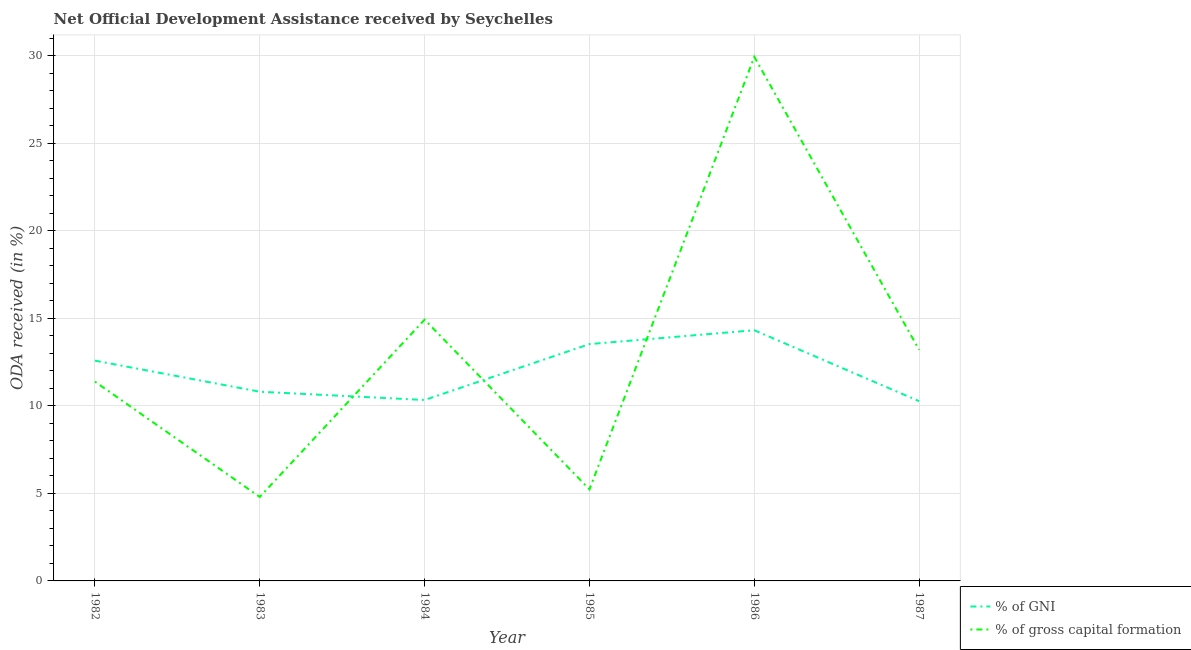Does the line corresponding to oda received as percentage of gross capital formation intersect with the line corresponding to oda received as percentage of gni?
Keep it short and to the point. Yes. What is the oda received as percentage of gross capital formation in 1983?
Provide a succinct answer. 4.8. Across all years, what is the maximum oda received as percentage of gni?
Keep it short and to the point. 14.32. Across all years, what is the minimum oda received as percentage of gni?
Your response must be concise. 10.26. In which year was the oda received as percentage of gross capital formation maximum?
Keep it short and to the point. 1986. In which year was the oda received as percentage of gross capital formation minimum?
Your response must be concise. 1983. What is the total oda received as percentage of gross capital formation in the graph?
Provide a succinct answer. 79.44. What is the difference between the oda received as percentage of gross capital formation in 1984 and that in 1985?
Provide a short and direct response. 9.69. What is the difference between the oda received as percentage of gni in 1986 and the oda received as percentage of gross capital formation in 1987?
Your response must be concise. 1.12. What is the average oda received as percentage of gross capital formation per year?
Offer a very short reply. 13.24. In the year 1984, what is the difference between the oda received as percentage of gross capital formation and oda received as percentage of gni?
Your response must be concise. 4.59. What is the ratio of the oda received as percentage of gni in 1984 to that in 1987?
Provide a short and direct response. 1.01. Is the oda received as percentage of gross capital formation in 1983 less than that in 1985?
Your answer should be very brief. Yes. Is the difference between the oda received as percentage of gni in 1982 and 1986 greater than the difference between the oda received as percentage of gross capital formation in 1982 and 1986?
Make the answer very short. Yes. What is the difference between the highest and the second highest oda received as percentage of gross capital formation?
Give a very brief answer. 15.01. What is the difference between the highest and the lowest oda received as percentage of gross capital formation?
Make the answer very short. 25.13. In how many years, is the oda received as percentage of gni greater than the average oda received as percentage of gni taken over all years?
Your response must be concise. 3. Is the oda received as percentage of gni strictly greater than the oda received as percentage of gross capital formation over the years?
Your response must be concise. No. Is the oda received as percentage of gross capital formation strictly less than the oda received as percentage of gni over the years?
Your answer should be very brief. No. How many years are there in the graph?
Offer a terse response. 6. Are the values on the major ticks of Y-axis written in scientific E-notation?
Keep it short and to the point. No. Does the graph contain grids?
Offer a very short reply. Yes. Where does the legend appear in the graph?
Offer a very short reply. Bottom right. What is the title of the graph?
Your response must be concise. Net Official Development Assistance received by Seychelles. Does "National Visitors" appear as one of the legend labels in the graph?
Your response must be concise. No. What is the label or title of the Y-axis?
Provide a short and direct response. ODA received (in %). What is the ODA received (in %) in % of GNI in 1982?
Ensure brevity in your answer.  12.58. What is the ODA received (in %) of % of gross capital formation in 1982?
Your response must be concise. 11.38. What is the ODA received (in %) of % of GNI in 1983?
Make the answer very short. 10.8. What is the ODA received (in %) in % of gross capital formation in 1983?
Offer a terse response. 4.8. What is the ODA received (in %) in % of GNI in 1984?
Provide a succinct answer. 10.33. What is the ODA received (in %) of % of gross capital formation in 1984?
Your answer should be compact. 14.92. What is the ODA received (in %) in % of GNI in 1985?
Provide a short and direct response. 13.52. What is the ODA received (in %) of % of gross capital formation in 1985?
Provide a short and direct response. 5.23. What is the ODA received (in %) in % of GNI in 1986?
Offer a very short reply. 14.32. What is the ODA received (in %) of % of gross capital formation in 1986?
Your answer should be very brief. 29.92. What is the ODA received (in %) of % of GNI in 1987?
Your response must be concise. 10.26. What is the ODA received (in %) in % of gross capital formation in 1987?
Keep it short and to the point. 13.19. Across all years, what is the maximum ODA received (in %) in % of GNI?
Your response must be concise. 14.32. Across all years, what is the maximum ODA received (in %) of % of gross capital formation?
Offer a terse response. 29.92. Across all years, what is the minimum ODA received (in %) of % of GNI?
Make the answer very short. 10.26. Across all years, what is the minimum ODA received (in %) in % of gross capital formation?
Provide a succinct answer. 4.8. What is the total ODA received (in %) of % of GNI in the graph?
Your answer should be very brief. 71.82. What is the total ODA received (in %) in % of gross capital formation in the graph?
Your answer should be very brief. 79.44. What is the difference between the ODA received (in %) of % of GNI in 1982 and that in 1983?
Your answer should be very brief. 1.78. What is the difference between the ODA received (in %) in % of gross capital formation in 1982 and that in 1983?
Make the answer very short. 6.59. What is the difference between the ODA received (in %) in % of GNI in 1982 and that in 1984?
Make the answer very short. 2.25. What is the difference between the ODA received (in %) in % of gross capital formation in 1982 and that in 1984?
Give a very brief answer. -3.54. What is the difference between the ODA received (in %) of % of GNI in 1982 and that in 1985?
Provide a short and direct response. -0.94. What is the difference between the ODA received (in %) in % of gross capital formation in 1982 and that in 1985?
Give a very brief answer. 6.15. What is the difference between the ODA received (in %) of % of GNI in 1982 and that in 1986?
Give a very brief answer. -1.74. What is the difference between the ODA received (in %) in % of gross capital formation in 1982 and that in 1986?
Your answer should be compact. -18.54. What is the difference between the ODA received (in %) in % of GNI in 1982 and that in 1987?
Offer a terse response. 2.32. What is the difference between the ODA received (in %) in % of gross capital formation in 1982 and that in 1987?
Ensure brevity in your answer.  -1.81. What is the difference between the ODA received (in %) in % of GNI in 1983 and that in 1984?
Provide a succinct answer. 0.47. What is the difference between the ODA received (in %) in % of gross capital formation in 1983 and that in 1984?
Provide a succinct answer. -10.12. What is the difference between the ODA received (in %) of % of GNI in 1983 and that in 1985?
Provide a short and direct response. -2.72. What is the difference between the ODA received (in %) of % of gross capital formation in 1983 and that in 1985?
Your response must be concise. -0.43. What is the difference between the ODA received (in %) in % of GNI in 1983 and that in 1986?
Keep it short and to the point. -3.51. What is the difference between the ODA received (in %) of % of gross capital formation in 1983 and that in 1986?
Make the answer very short. -25.13. What is the difference between the ODA received (in %) in % of GNI in 1983 and that in 1987?
Your answer should be very brief. 0.54. What is the difference between the ODA received (in %) in % of gross capital formation in 1983 and that in 1987?
Ensure brevity in your answer.  -8.4. What is the difference between the ODA received (in %) of % of GNI in 1984 and that in 1985?
Provide a succinct answer. -3.19. What is the difference between the ODA received (in %) in % of gross capital formation in 1984 and that in 1985?
Your response must be concise. 9.69. What is the difference between the ODA received (in %) of % of GNI in 1984 and that in 1986?
Provide a short and direct response. -3.98. What is the difference between the ODA received (in %) in % of gross capital formation in 1984 and that in 1986?
Make the answer very short. -15.01. What is the difference between the ODA received (in %) of % of GNI in 1984 and that in 1987?
Ensure brevity in your answer.  0.07. What is the difference between the ODA received (in %) of % of gross capital formation in 1984 and that in 1987?
Ensure brevity in your answer.  1.73. What is the difference between the ODA received (in %) of % of GNI in 1985 and that in 1986?
Your answer should be very brief. -0.79. What is the difference between the ODA received (in %) of % of gross capital formation in 1985 and that in 1986?
Offer a very short reply. -24.7. What is the difference between the ODA received (in %) in % of GNI in 1985 and that in 1987?
Provide a short and direct response. 3.26. What is the difference between the ODA received (in %) of % of gross capital formation in 1985 and that in 1987?
Your answer should be compact. -7.96. What is the difference between the ODA received (in %) of % of GNI in 1986 and that in 1987?
Your response must be concise. 4.05. What is the difference between the ODA received (in %) in % of gross capital formation in 1986 and that in 1987?
Make the answer very short. 16.73. What is the difference between the ODA received (in %) in % of GNI in 1982 and the ODA received (in %) in % of gross capital formation in 1983?
Your answer should be compact. 7.78. What is the difference between the ODA received (in %) in % of GNI in 1982 and the ODA received (in %) in % of gross capital formation in 1984?
Keep it short and to the point. -2.34. What is the difference between the ODA received (in %) of % of GNI in 1982 and the ODA received (in %) of % of gross capital formation in 1985?
Give a very brief answer. 7.35. What is the difference between the ODA received (in %) in % of GNI in 1982 and the ODA received (in %) in % of gross capital formation in 1986?
Make the answer very short. -17.34. What is the difference between the ODA received (in %) of % of GNI in 1982 and the ODA received (in %) of % of gross capital formation in 1987?
Your response must be concise. -0.61. What is the difference between the ODA received (in %) in % of GNI in 1983 and the ODA received (in %) in % of gross capital formation in 1984?
Provide a succinct answer. -4.12. What is the difference between the ODA received (in %) in % of GNI in 1983 and the ODA received (in %) in % of gross capital formation in 1985?
Your response must be concise. 5.57. What is the difference between the ODA received (in %) of % of GNI in 1983 and the ODA received (in %) of % of gross capital formation in 1986?
Offer a terse response. -19.12. What is the difference between the ODA received (in %) of % of GNI in 1983 and the ODA received (in %) of % of gross capital formation in 1987?
Make the answer very short. -2.39. What is the difference between the ODA received (in %) in % of GNI in 1984 and the ODA received (in %) in % of gross capital formation in 1985?
Ensure brevity in your answer.  5.1. What is the difference between the ODA received (in %) of % of GNI in 1984 and the ODA received (in %) of % of gross capital formation in 1986?
Keep it short and to the point. -19.59. What is the difference between the ODA received (in %) in % of GNI in 1984 and the ODA received (in %) in % of gross capital formation in 1987?
Offer a very short reply. -2.86. What is the difference between the ODA received (in %) in % of GNI in 1985 and the ODA received (in %) in % of gross capital formation in 1986?
Ensure brevity in your answer.  -16.4. What is the difference between the ODA received (in %) in % of GNI in 1985 and the ODA received (in %) in % of gross capital formation in 1987?
Your answer should be compact. 0.33. What is the difference between the ODA received (in %) of % of GNI in 1986 and the ODA received (in %) of % of gross capital formation in 1987?
Give a very brief answer. 1.12. What is the average ODA received (in %) of % of GNI per year?
Your answer should be compact. 11.97. What is the average ODA received (in %) in % of gross capital formation per year?
Your response must be concise. 13.24. In the year 1982, what is the difference between the ODA received (in %) of % of GNI and ODA received (in %) of % of gross capital formation?
Your response must be concise. 1.2. In the year 1983, what is the difference between the ODA received (in %) of % of GNI and ODA received (in %) of % of gross capital formation?
Keep it short and to the point. 6.01. In the year 1984, what is the difference between the ODA received (in %) in % of GNI and ODA received (in %) in % of gross capital formation?
Ensure brevity in your answer.  -4.59. In the year 1985, what is the difference between the ODA received (in %) of % of GNI and ODA received (in %) of % of gross capital formation?
Ensure brevity in your answer.  8.29. In the year 1986, what is the difference between the ODA received (in %) of % of GNI and ODA received (in %) of % of gross capital formation?
Provide a short and direct response. -15.61. In the year 1987, what is the difference between the ODA received (in %) of % of GNI and ODA received (in %) of % of gross capital formation?
Provide a short and direct response. -2.93. What is the ratio of the ODA received (in %) in % of GNI in 1982 to that in 1983?
Your answer should be very brief. 1.16. What is the ratio of the ODA received (in %) of % of gross capital formation in 1982 to that in 1983?
Offer a terse response. 2.37. What is the ratio of the ODA received (in %) of % of GNI in 1982 to that in 1984?
Your response must be concise. 1.22. What is the ratio of the ODA received (in %) of % of gross capital formation in 1982 to that in 1984?
Offer a terse response. 0.76. What is the ratio of the ODA received (in %) in % of GNI in 1982 to that in 1985?
Offer a very short reply. 0.93. What is the ratio of the ODA received (in %) of % of gross capital formation in 1982 to that in 1985?
Offer a very short reply. 2.18. What is the ratio of the ODA received (in %) of % of GNI in 1982 to that in 1986?
Provide a succinct answer. 0.88. What is the ratio of the ODA received (in %) of % of gross capital formation in 1982 to that in 1986?
Give a very brief answer. 0.38. What is the ratio of the ODA received (in %) in % of GNI in 1982 to that in 1987?
Your answer should be compact. 1.23. What is the ratio of the ODA received (in %) in % of gross capital formation in 1982 to that in 1987?
Your answer should be very brief. 0.86. What is the ratio of the ODA received (in %) in % of GNI in 1983 to that in 1984?
Keep it short and to the point. 1.05. What is the ratio of the ODA received (in %) of % of gross capital formation in 1983 to that in 1984?
Give a very brief answer. 0.32. What is the ratio of the ODA received (in %) of % of GNI in 1983 to that in 1985?
Keep it short and to the point. 0.8. What is the ratio of the ODA received (in %) in % of gross capital formation in 1983 to that in 1985?
Provide a succinct answer. 0.92. What is the ratio of the ODA received (in %) of % of GNI in 1983 to that in 1986?
Provide a succinct answer. 0.75. What is the ratio of the ODA received (in %) of % of gross capital formation in 1983 to that in 1986?
Provide a succinct answer. 0.16. What is the ratio of the ODA received (in %) of % of GNI in 1983 to that in 1987?
Your response must be concise. 1.05. What is the ratio of the ODA received (in %) of % of gross capital formation in 1983 to that in 1987?
Your response must be concise. 0.36. What is the ratio of the ODA received (in %) of % of GNI in 1984 to that in 1985?
Give a very brief answer. 0.76. What is the ratio of the ODA received (in %) in % of gross capital formation in 1984 to that in 1985?
Give a very brief answer. 2.85. What is the ratio of the ODA received (in %) of % of GNI in 1984 to that in 1986?
Your answer should be compact. 0.72. What is the ratio of the ODA received (in %) of % of gross capital formation in 1984 to that in 1986?
Offer a very short reply. 0.5. What is the ratio of the ODA received (in %) of % of GNI in 1984 to that in 1987?
Provide a short and direct response. 1.01. What is the ratio of the ODA received (in %) of % of gross capital formation in 1984 to that in 1987?
Your answer should be compact. 1.13. What is the ratio of the ODA received (in %) in % of GNI in 1985 to that in 1986?
Your answer should be compact. 0.94. What is the ratio of the ODA received (in %) of % of gross capital formation in 1985 to that in 1986?
Make the answer very short. 0.17. What is the ratio of the ODA received (in %) in % of GNI in 1985 to that in 1987?
Make the answer very short. 1.32. What is the ratio of the ODA received (in %) of % of gross capital formation in 1985 to that in 1987?
Make the answer very short. 0.4. What is the ratio of the ODA received (in %) of % of GNI in 1986 to that in 1987?
Your response must be concise. 1.39. What is the ratio of the ODA received (in %) in % of gross capital formation in 1986 to that in 1987?
Provide a succinct answer. 2.27. What is the difference between the highest and the second highest ODA received (in %) in % of GNI?
Offer a very short reply. 0.79. What is the difference between the highest and the second highest ODA received (in %) in % of gross capital formation?
Keep it short and to the point. 15.01. What is the difference between the highest and the lowest ODA received (in %) in % of GNI?
Make the answer very short. 4.05. What is the difference between the highest and the lowest ODA received (in %) of % of gross capital formation?
Your answer should be compact. 25.13. 